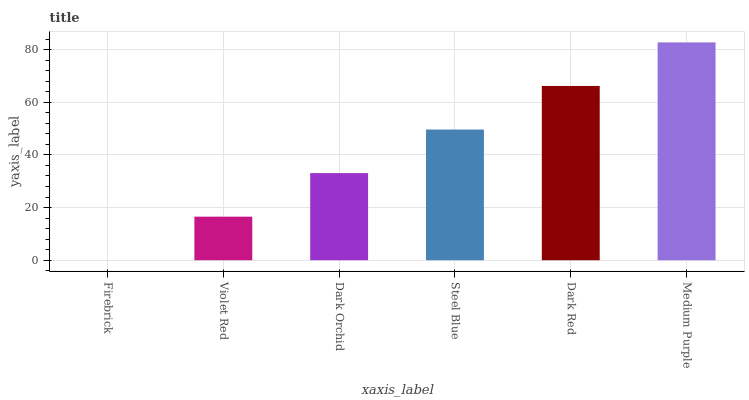Is Violet Red the minimum?
Answer yes or no. No. Is Violet Red the maximum?
Answer yes or no. No. Is Violet Red greater than Firebrick?
Answer yes or no. Yes. Is Firebrick less than Violet Red?
Answer yes or no. Yes. Is Firebrick greater than Violet Red?
Answer yes or no. No. Is Violet Red less than Firebrick?
Answer yes or no. No. Is Steel Blue the high median?
Answer yes or no. Yes. Is Dark Orchid the low median?
Answer yes or no. Yes. Is Firebrick the high median?
Answer yes or no. No. Is Steel Blue the low median?
Answer yes or no. No. 